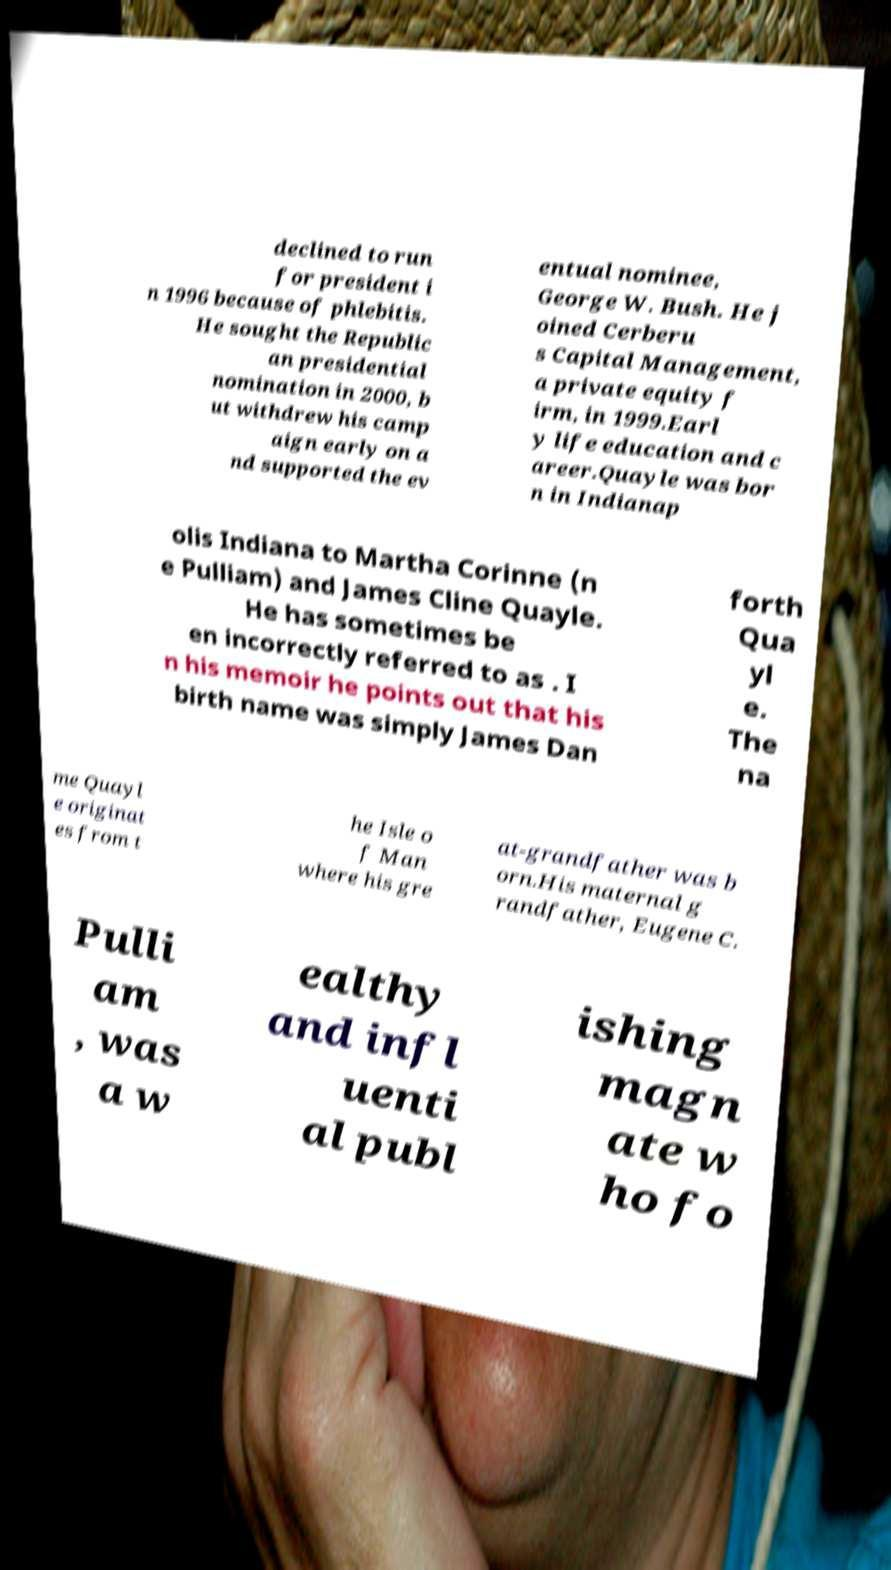Please identify and transcribe the text found in this image. declined to run for president i n 1996 because of phlebitis. He sought the Republic an presidential nomination in 2000, b ut withdrew his camp aign early on a nd supported the ev entual nominee, George W. Bush. He j oined Cerberu s Capital Management, a private equity f irm, in 1999.Earl y life education and c areer.Quayle was bor n in Indianap olis Indiana to Martha Corinne (n e Pulliam) and James Cline Quayle. He has sometimes be en incorrectly referred to as . I n his memoir he points out that his birth name was simply James Dan forth Qua yl e. The na me Quayl e originat es from t he Isle o f Man where his gre at-grandfather was b orn.His maternal g randfather, Eugene C. Pulli am , was a w ealthy and infl uenti al publ ishing magn ate w ho fo 